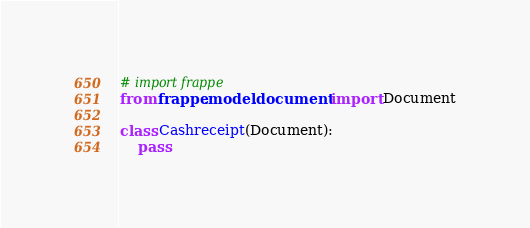Convert code to text. <code><loc_0><loc_0><loc_500><loc_500><_Python_>
# import frappe
from frappe.model.document import Document

class Cashreceipt(Document):
	pass
</code> 